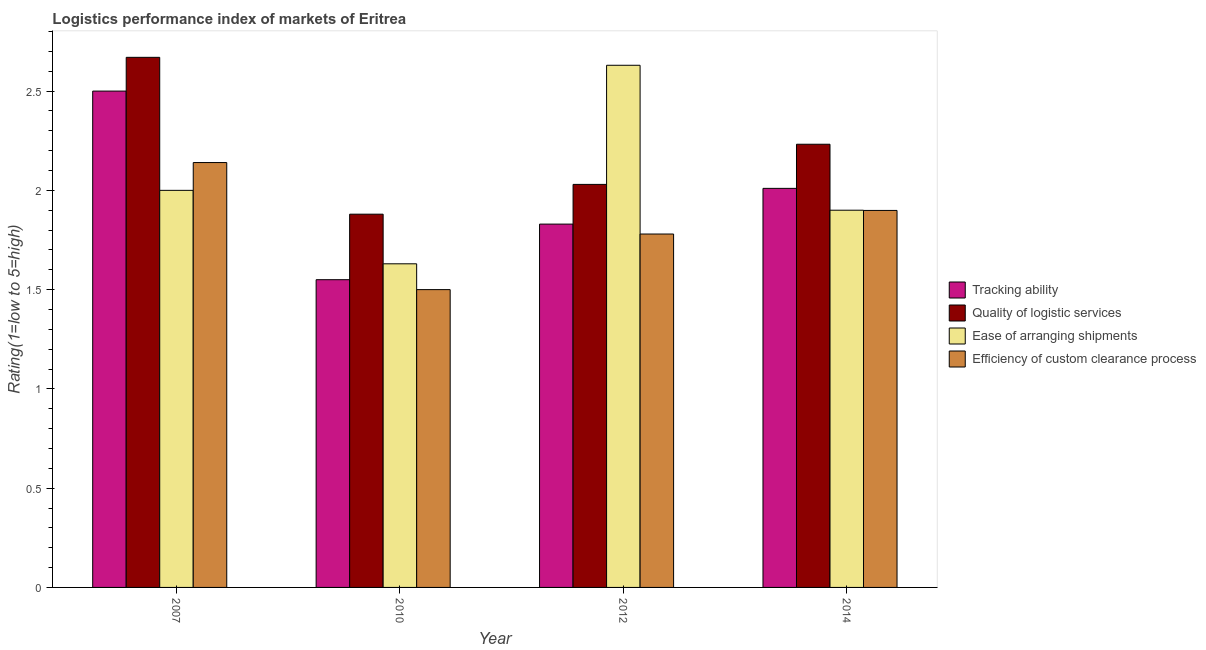How many groups of bars are there?
Your response must be concise. 4. How many bars are there on the 2nd tick from the left?
Your answer should be compact. 4. What is the label of the 4th group of bars from the left?
Your answer should be compact. 2014. What is the lpi rating of ease of arranging shipments in 2012?
Give a very brief answer. 2.63. Across all years, what is the maximum lpi rating of ease of arranging shipments?
Offer a terse response. 2.63. Across all years, what is the minimum lpi rating of tracking ability?
Your answer should be very brief. 1.55. What is the total lpi rating of tracking ability in the graph?
Give a very brief answer. 7.89. What is the difference between the lpi rating of quality of logistic services in 2010 and that in 2012?
Keep it short and to the point. -0.15. What is the difference between the lpi rating of quality of logistic services in 2010 and the lpi rating of ease of arranging shipments in 2007?
Give a very brief answer. -0.79. What is the average lpi rating of ease of arranging shipments per year?
Ensure brevity in your answer.  2.04. What is the ratio of the lpi rating of tracking ability in 2007 to that in 2014?
Keep it short and to the point. 1.24. What is the difference between the highest and the second highest lpi rating of ease of arranging shipments?
Your answer should be very brief. 0.63. What is the difference between the highest and the lowest lpi rating of quality of logistic services?
Ensure brevity in your answer.  0.79. What does the 4th bar from the left in 2007 represents?
Offer a very short reply. Efficiency of custom clearance process. What does the 3rd bar from the right in 2014 represents?
Provide a succinct answer. Quality of logistic services. How many bars are there?
Offer a very short reply. 16. How many years are there in the graph?
Your answer should be very brief. 4. Are the values on the major ticks of Y-axis written in scientific E-notation?
Your answer should be very brief. No. Does the graph contain grids?
Give a very brief answer. No. How are the legend labels stacked?
Your answer should be compact. Vertical. What is the title of the graph?
Your answer should be very brief. Logistics performance index of markets of Eritrea. What is the label or title of the X-axis?
Your answer should be very brief. Year. What is the label or title of the Y-axis?
Keep it short and to the point. Rating(1=low to 5=high). What is the Rating(1=low to 5=high) in Tracking ability in 2007?
Keep it short and to the point. 2.5. What is the Rating(1=low to 5=high) of Quality of logistic services in 2007?
Offer a very short reply. 2.67. What is the Rating(1=low to 5=high) of Efficiency of custom clearance process in 2007?
Your response must be concise. 2.14. What is the Rating(1=low to 5=high) of Tracking ability in 2010?
Offer a terse response. 1.55. What is the Rating(1=low to 5=high) of Quality of logistic services in 2010?
Offer a very short reply. 1.88. What is the Rating(1=low to 5=high) in Ease of arranging shipments in 2010?
Keep it short and to the point. 1.63. What is the Rating(1=low to 5=high) in Tracking ability in 2012?
Your answer should be very brief. 1.83. What is the Rating(1=low to 5=high) in Quality of logistic services in 2012?
Your answer should be compact. 2.03. What is the Rating(1=low to 5=high) in Ease of arranging shipments in 2012?
Ensure brevity in your answer.  2.63. What is the Rating(1=low to 5=high) of Efficiency of custom clearance process in 2012?
Provide a short and direct response. 1.78. What is the Rating(1=low to 5=high) in Tracking ability in 2014?
Make the answer very short. 2.01. What is the Rating(1=low to 5=high) in Quality of logistic services in 2014?
Make the answer very short. 2.23. What is the Rating(1=low to 5=high) of Ease of arranging shipments in 2014?
Ensure brevity in your answer.  1.9. What is the Rating(1=low to 5=high) of Efficiency of custom clearance process in 2014?
Provide a short and direct response. 1.9. Across all years, what is the maximum Rating(1=low to 5=high) of Tracking ability?
Your response must be concise. 2.5. Across all years, what is the maximum Rating(1=low to 5=high) in Quality of logistic services?
Your answer should be very brief. 2.67. Across all years, what is the maximum Rating(1=low to 5=high) in Ease of arranging shipments?
Your answer should be compact. 2.63. Across all years, what is the maximum Rating(1=low to 5=high) in Efficiency of custom clearance process?
Offer a terse response. 2.14. Across all years, what is the minimum Rating(1=low to 5=high) in Tracking ability?
Your answer should be compact. 1.55. Across all years, what is the minimum Rating(1=low to 5=high) of Quality of logistic services?
Offer a terse response. 1.88. Across all years, what is the minimum Rating(1=low to 5=high) in Ease of arranging shipments?
Your answer should be very brief. 1.63. What is the total Rating(1=low to 5=high) of Tracking ability in the graph?
Offer a terse response. 7.89. What is the total Rating(1=low to 5=high) in Quality of logistic services in the graph?
Your response must be concise. 8.81. What is the total Rating(1=low to 5=high) in Ease of arranging shipments in the graph?
Your response must be concise. 8.16. What is the total Rating(1=low to 5=high) of Efficiency of custom clearance process in the graph?
Provide a short and direct response. 7.32. What is the difference between the Rating(1=low to 5=high) in Tracking ability in 2007 and that in 2010?
Make the answer very short. 0.95. What is the difference between the Rating(1=low to 5=high) of Quality of logistic services in 2007 and that in 2010?
Provide a succinct answer. 0.79. What is the difference between the Rating(1=low to 5=high) of Ease of arranging shipments in 2007 and that in 2010?
Make the answer very short. 0.37. What is the difference between the Rating(1=low to 5=high) of Efficiency of custom clearance process in 2007 and that in 2010?
Make the answer very short. 0.64. What is the difference between the Rating(1=low to 5=high) in Tracking ability in 2007 and that in 2012?
Ensure brevity in your answer.  0.67. What is the difference between the Rating(1=low to 5=high) in Quality of logistic services in 2007 and that in 2012?
Make the answer very short. 0.64. What is the difference between the Rating(1=low to 5=high) in Ease of arranging shipments in 2007 and that in 2012?
Keep it short and to the point. -0.63. What is the difference between the Rating(1=low to 5=high) in Efficiency of custom clearance process in 2007 and that in 2012?
Offer a terse response. 0.36. What is the difference between the Rating(1=low to 5=high) of Tracking ability in 2007 and that in 2014?
Offer a terse response. 0.49. What is the difference between the Rating(1=low to 5=high) in Quality of logistic services in 2007 and that in 2014?
Keep it short and to the point. 0.44. What is the difference between the Rating(1=low to 5=high) in Ease of arranging shipments in 2007 and that in 2014?
Keep it short and to the point. 0.1. What is the difference between the Rating(1=low to 5=high) of Efficiency of custom clearance process in 2007 and that in 2014?
Provide a short and direct response. 0.24. What is the difference between the Rating(1=low to 5=high) of Tracking ability in 2010 and that in 2012?
Make the answer very short. -0.28. What is the difference between the Rating(1=low to 5=high) in Quality of logistic services in 2010 and that in 2012?
Your response must be concise. -0.15. What is the difference between the Rating(1=low to 5=high) in Ease of arranging shipments in 2010 and that in 2012?
Ensure brevity in your answer.  -1. What is the difference between the Rating(1=low to 5=high) of Efficiency of custom clearance process in 2010 and that in 2012?
Keep it short and to the point. -0.28. What is the difference between the Rating(1=low to 5=high) in Tracking ability in 2010 and that in 2014?
Offer a terse response. -0.46. What is the difference between the Rating(1=low to 5=high) in Quality of logistic services in 2010 and that in 2014?
Your answer should be very brief. -0.35. What is the difference between the Rating(1=low to 5=high) of Ease of arranging shipments in 2010 and that in 2014?
Your answer should be very brief. -0.27. What is the difference between the Rating(1=low to 5=high) in Efficiency of custom clearance process in 2010 and that in 2014?
Give a very brief answer. -0.4. What is the difference between the Rating(1=low to 5=high) of Tracking ability in 2012 and that in 2014?
Your answer should be very brief. -0.18. What is the difference between the Rating(1=low to 5=high) in Quality of logistic services in 2012 and that in 2014?
Your answer should be very brief. -0.2. What is the difference between the Rating(1=low to 5=high) in Ease of arranging shipments in 2012 and that in 2014?
Your response must be concise. 0.73. What is the difference between the Rating(1=low to 5=high) of Efficiency of custom clearance process in 2012 and that in 2014?
Keep it short and to the point. -0.12. What is the difference between the Rating(1=low to 5=high) in Tracking ability in 2007 and the Rating(1=low to 5=high) in Quality of logistic services in 2010?
Ensure brevity in your answer.  0.62. What is the difference between the Rating(1=low to 5=high) in Tracking ability in 2007 and the Rating(1=low to 5=high) in Ease of arranging shipments in 2010?
Offer a very short reply. 0.87. What is the difference between the Rating(1=low to 5=high) in Tracking ability in 2007 and the Rating(1=low to 5=high) in Efficiency of custom clearance process in 2010?
Keep it short and to the point. 1. What is the difference between the Rating(1=low to 5=high) in Quality of logistic services in 2007 and the Rating(1=low to 5=high) in Efficiency of custom clearance process in 2010?
Ensure brevity in your answer.  1.17. What is the difference between the Rating(1=low to 5=high) of Tracking ability in 2007 and the Rating(1=low to 5=high) of Quality of logistic services in 2012?
Offer a very short reply. 0.47. What is the difference between the Rating(1=low to 5=high) in Tracking ability in 2007 and the Rating(1=low to 5=high) in Ease of arranging shipments in 2012?
Provide a succinct answer. -0.13. What is the difference between the Rating(1=low to 5=high) of Tracking ability in 2007 and the Rating(1=low to 5=high) of Efficiency of custom clearance process in 2012?
Provide a short and direct response. 0.72. What is the difference between the Rating(1=low to 5=high) of Quality of logistic services in 2007 and the Rating(1=low to 5=high) of Efficiency of custom clearance process in 2012?
Your answer should be very brief. 0.89. What is the difference between the Rating(1=low to 5=high) in Ease of arranging shipments in 2007 and the Rating(1=low to 5=high) in Efficiency of custom clearance process in 2012?
Provide a succinct answer. 0.22. What is the difference between the Rating(1=low to 5=high) of Tracking ability in 2007 and the Rating(1=low to 5=high) of Quality of logistic services in 2014?
Offer a very short reply. 0.27. What is the difference between the Rating(1=low to 5=high) of Tracking ability in 2007 and the Rating(1=low to 5=high) of Ease of arranging shipments in 2014?
Offer a terse response. 0.6. What is the difference between the Rating(1=low to 5=high) of Tracking ability in 2007 and the Rating(1=low to 5=high) of Efficiency of custom clearance process in 2014?
Ensure brevity in your answer.  0.6. What is the difference between the Rating(1=low to 5=high) in Quality of logistic services in 2007 and the Rating(1=low to 5=high) in Ease of arranging shipments in 2014?
Your response must be concise. 0.77. What is the difference between the Rating(1=low to 5=high) of Quality of logistic services in 2007 and the Rating(1=low to 5=high) of Efficiency of custom clearance process in 2014?
Provide a succinct answer. 0.77. What is the difference between the Rating(1=low to 5=high) in Ease of arranging shipments in 2007 and the Rating(1=low to 5=high) in Efficiency of custom clearance process in 2014?
Give a very brief answer. 0.1. What is the difference between the Rating(1=low to 5=high) of Tracking ability in 2010 and the Rating(1=low to 5=high) of Quality of logistic services in 2012?
Offer a terse response. -0.48. What is the difference between the Rating(1=low to 5=high) of Tracking ability in 2010 and the Rating(1=low to 5=high) of Ease of arranging shipments in 2012?
Give a very brief answer. -1.08. What is the difference between the Rating(1=low to 5=high) in Tracking ability in 2010 and the Rating(1=low to 5=high) in Efficiency of custom clearance process in 2012?
Give a very brief answer. -0.23. What is the difference between the Rating(1=low to 5=high) in Quality of logistic services in 2010 and the Rating(1=low to 5=high) in Ease of arranging shipments in 2012?
Provide a succinct answer. -0.75. What is the difference between the Rating(1=low to 5=high) in Tracking ability in 2010 and the Rating(1=low to 5=high) in Quality of logistic services in 2014?
Make the answer very short. -0.68. What is the difference between the Rating(1=low to 5=high) of Tracking ability in 2010 and the Rating(1=low to 5=high) of Ease of arranging shipments in 2014?
Ensure brevity in your answer.  -0.35. What is the difference between the Rating(1=low to 5=high) in Tracking ability in 2010 and the Rating(1=low to 5=high) in Efficiency of custom clearance process in 2014?
Provide a short and direct response. -0.35. What is the difference between the Rating(1=low to 5=high) of Quality of logistic services in 2010 and the Rating(1=low to 5=high) of Ease of arranging shipments in 2014?
Provide a short and direct response. -0.02. What is the difference between the Rating(1=low to 5=high) of Quality of logistic services in 2010 and the Rating(1=low to 5=high) of Efficiency of custom clearance process in 2014?
Keep it short and to the point. -0.02. What is the difference between the Rating(1=low to 5=high) in Ease of arranging shipments in 2010 and the Rating(1=low to 5=high) in Efficiency of custom clearance process in 2014?
Keep it short and to the point. -0.27. What is the difference between the Rating(1=low to 5=high) in Tracking ability in 2012 and the Rating(1=low to 5=high) in Quality of logistic services in 2014?
Offer a terse response. -0.4. What is the difference between the Rating(1=low to 5=high) of Tracking ability in 2012 and the Rating(1=low to 5=high) of Ease of arranging shipments in 2014?
Your answer should be very brief. -0.07. What is the difference between the Rating(1=low to 5=high) of Tracking ability in 2012 and the Rating(1=low to 5=high) of Efficiency of custom clearance process in 2014?
Provide a short and direct response. -0.07. What is the difference between the Rating(1=low to 5=high) of Quality of logistic services in 2012 and the Rating(1=low to 5=high) of Ease of arranging shipments in 2014?
Offer a terse response. 0.13. What is the difference between the Rating(1=low to 5=high) in Quality of logistic services in 2012 and the Rating(1=low to 5=high) in Efficiency of custom clearance process in 2014?
Offer a very short reply. 0.13. What is the difference between the Rating(1=low to 5=high) in Ease of arranging shipments in 2012 and the Rating(1=low to 5=high) in Efficiency of custom clearance process in 2014?
Your answer should be compact. 0.73. What is the average Rating(1=low to 5=high) of Tracking ability per year?
Offer a very short reply. 1.97. What is the average Rating(1=low to 5=high) in Quality of logistic services per year?
Offer a very short reply. 2.2. What is the average Rating(1=low to 5=high) in Ease of arranging shipments per year?
Ensure brevity in your answer.  2.04. What is the average Rating(1=low to 5=high) in Efficiency of custom clearance process per year?
Offer a terse response. 1.83. In the year 2007, what is the difference between the Rating(1=low to 5=high) of Tracking ability and Rating(1=low to 5=high) of Quality of logistic services?
Your response must be concise. -0.17. In the year 2007, what is the difference between the Rating(1=low to 5=high) of Tracking ability and Rating(1=low to 5=high) of Ease of arranging shipments?
Provide a succinct answer. 0.5. In the year 2007, what is the difference between the Rating(1=low to 5=high) of Tracking ability and Rating(1=low to 5=high) of Efficiency of custom clearance process?
Your response must be concise. 0.36. In the year 2007, what is the difference between the Rating(1=low to 5=high) in Quality of logistic services and Rating(1=low to 5=high) in Ease of arranging shipments?
Your answer should be compact. 0.67. In the year 2007, what is the difference between the Rating(1=low to 5=high) in Quality of logistic services and Rating(1=low to 5=high) in Efficiency of custom clearance process?
Give a very brief answer. 0.53. In the year 2007, what is the difference between the Rating(1=low to 5=high) of Ease of arranging shipments and Rating(1=low to 5=high) of Efficiency of custom clearance process?
Keep it short and to the point. -0.14. In the year 2010, what is the difference between the Rating(1=low to 5=high) in Tracking ability and Rating(1=low to 5=high) in Quality of logistic services?
Offer a very short reply. -0.33. In the year 2010, what is the difference between the Rating(1=low to 5=high) of Tracking ability and Rating(1=low to 5=high) of Ease of arranging shipments?
Offer a very short reply. -0.08. In the year 2010, what is the difference between the Rating(1=low to 5=high) of Quality of logistic services and Rating(1=low to 5=high) of Ease of arranging shipments?
Your response must be concise. 0.25. In the year 2010, what is the difference between the Rating(1=low to 5=high) of Quality of logistic services and Rating(1=low to 5=high) of Efficiency of custom clearance process?
Give a very brief answer. 0.38. In the year 2010, what is the difference between the Rating(1=low to 5=high) of Ease of arranging shipments and Rating(1=low to 5=high) of Efficiency of custom clearance process?
Offer a terse response. 0.13. In the year 2012, what is the difference between the Rating(1=low to 5=high) of Tracking ability and Rating(1=low to 5=high) of Efficiency of custom clearance process?
Your response must be concise. 0.05. In the year 2012, what is the difference between the Rating(1=low to 5=high) in Quality of logistic services and Rating(1=low to 5=high) in Ease of arranging shipments?
Provide a short and direct response. -0.6. In the year 2012, what is the difference between the Rating(1=low to 5=high) in Quality of logistic services and Rating(1=low to 5=high) in Efficiency of custom clearance process?
Give a very brief answer. 0.25. In the year 2012, what is the difference between the Rating(1=low to 5=high) of Ease of arranging shipments and Rating(1=low to 5=high) of Efficiency of custom clearance process?
Provide a short and direct response. 0.85. In the year 2014, what is the difference between the Rating(1=low to 5=high) of Tracking ability and Rating(1=low to 5=high) of Quality of logistic services?
Give a very brief answer. -0.22. In the year 2014, what is the difference between the Rating(1=low to 5=high) of Tracking ability and Rating(1=low to 5=high) of Ease of arranging shipments?
Provide a succinct answer. 0.11. In the year 2014, what is the difference between the Rating(1=low to 5=high) in Quality of logistic services and Rating(1=low to 5=high) in Ease of arranging shipments?
Offer a very short reply. 0.33. In the year 2014, what is the difference between the Rating(1=low to 5=high) of Quality of logistic services and Rating(1=low to 5=high) of Efficiency of custom clearance process?
Provide a short and direct response. 0.33. In the year 2014, what is the difference between the Rating(1=low to 5=high) in Ease of arranging shipments and Rating(1=low to 5=high) in Efficiency of custom clearance process?
Offer a terse response. 0. What is the ratio of the Rating(1=low to 5=high) of Tracking ability in 2007 to that in 2010?
Your response must be concise. 1.61. What is the ratio of the Rating(1=low to 5=high) of Quality of logistic services in 2007 to that in 2010?
Offer a very short reply. 1.42. What is the ratio of the Rating(1=low to 5=high) of Ease of arranging shipments in 2007 to that in 2010?
Provide a short and direct response. 1.23. What is the ratio of the Rating(1=low to 5=high) in Efficiency of custom clearance process in 2007 to that in 2010?
Provide a short and direct response. 1.43. What is the ratio of the Rating(1=low to 5=high) in Tracking ability in 2007 to that in 2012?
Your response must be concise. 1.37. What is the ratio of the Rating(1=low to 5=high) of Quality of logistic services in 2007 to that in 2012?
Give a very brief answer. 1.32. What is the ratio of the Rating(1=low to 5=high) of Ease of arranging shipments in 2007 to that in 2012?
Keep it short and to the point. 0.76. What is the ratio of the Rating(1=low to 5=high) in Efficiency of custom clearance process in 2007 to that in 2012?
Offer a very short reply. 1.2. What is the ratio of the Rating(1=low to 5=high) in Tracking ability in 2007 to that in 2014?
Make the answer very short. 1.24. What is the ratio of the Rating(1=low to 5=high) in Quality of logistic services in 2007 to that in 2014?
Offer a terse response. 1.2. What is the ratio of the Rating(1=low to 5=high) of Ease of arranging shipments in 2007 to that in 2014?
Provide a short and direct response. 1.05. What is the ratio of the Rating(1=low to 5=high) of Efficiency of custom clearance process in 2007 to that in 2014?
Make the answer very short. 1.13. What is the ratio of the Rating(1=low to 5=high) in Tracking ability in 2010 to that in 2012?
Provide a short and direct response. 0.85. What is the ratio of the Rating(1=low to 5=high) of Quality of logistic services in 2010 to that in 2012?
Your answer should be compact. 0.93. What is the ratio of the Rating(1=low to 5=high) of Ease of arranging shipments in 2010 to that in 2012?
Give a very brief answer. 0.62. What is the ratio of the Rating(1=low to 5=high) of Efficiency of custom clearance process in 2010 to that in 2012?
Keep it short and to the point. 0.84. What is the ratio of the Rating(1=low to 5=high) in Tracking ability in 2010 to that in 2014?
Give a very brief answer. 0.77. What is the ratio of the Rating(1=low to 5=high) of Quality of logistic services in 2010 to that in 2014?
Your answer should be compact. 0.84. What is the ratio of the Rating(1=low to 5=high) of Ease of arranging shipments in 2010 to that in 2014?
Provide a short and direct response. 0.86. What is the ratio of the Rating(1=low to 5=high) of Efficiency of custom clearance process in 2010 to that in 2014?
Ensure brevity in your answer.  0.79. What is the ratio of the Rating(1=low to 5=high) of Tracking ability in 2012 to that in 2014?
Your answer should be very brief. 0.91. What is the ratio of the Rating(1=low to 5=high) in Quality of logistic services in 2012 to that in 2014?
Offer a very short reply. 0.91. What is the ratio of the Rating(1=low to 5=high) in Ease of arranging shipments in 2012 to that in 2014?
Provide a short and direct response. 1.38. What is the ratio of the Rating(1=low to 5=high) in Efficiency of custom clearance process in 2012 to that in 2014?
Offer a terse response. 0.94. What is the difference between the highest and the second highest Rating(1=low to 5=high) of Tracking ability?
Your answer should be compact. 0.49. What is the difference between the highest and the second highest Rating(1=low to 5=high) of Quality of logistic services?
Ensure brevity in your answer.  0.44. What is the difference between the highest and the second highest Rating(1=low to 5=high) in Ease of arranging shipments?
Ensure brevity in your answer.  0.63. What is the difference between the highest and the second highest Rating(1=low to 5=high) in Efficiency of custom clearance process?
Your response must be concise. 0.24. What is the difference between the highest and the lowest Rating(1=low to 5=high) in Quality of logistic services?
Your answer should be compact. 0.79. What is the difference between the highest and the lowest Rating(1=low to 5=high) in Ease of arranging shipments?
Give a very brief answer. 1. What is the difference between the highest and the lowest Rating(1=low to 5=high) in Efficiency of custom clearance process?
Ensure brevity in your answer.  0.64. 